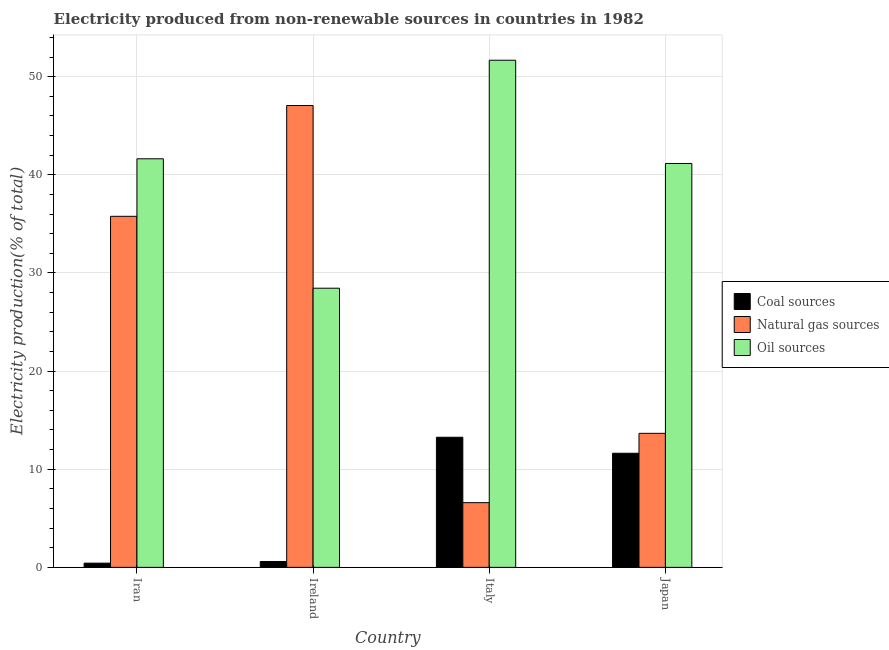How many different coloured bars are there?
Give a very brief answer. 3. How many bars are there on the 3rd tick from the left?
Offer a terse response. 3. What is the label of the 1st group of bars from the left?
Give a very brief answer. Iran. What is the percentage of electricity produced by coal in Iran?
Keep it short and to the point. 0.43. Across all countries, what is the maximum percentage of electricity produced by oil sources?
Provide a succinct answer. 51.67. Across all countries, what is the minimum percentage of electricity produced by oil sources?
Offer a very short reply. 28.44. In which country was the percentage of electricity produced by natural gas maximum?
Make the answer very short. Ireland. What is the total percentage of electricity produced by coal in the graph?
Your answer should be compact. 25.91. What is the difference between the percentage of electricity produced by oil sources in Iran and that in Ireland?
Your response must be concise. 13.19. What is the difference between the percentage of electricity produced by oil sources in Iran and the percentage of electricity produced by natural gas in Japan?
Provide a succinct answer. 27.97. What is the average percentage of electricity produced by natural gas per country?
Provide a succinct answer. 25.77. What is the difference between the percentage of electricity produced by coal and percentage of electricity produced by oil sources in Japan?
Your response must be concise. -29.52. What is the ratio of the percentage of electricity produced by coal in Italy to that in Japan?
Give a very brief answer. 1.14. What is the difference between the highest and the second highest percentage of electricity produced by natural gas?
Offer a terse response. 11.29. What is the difference between the highest and the lowest percentage of electricity produced by natural gas?
Your answer should be very brief. 40.46. In how many countries, is the percentage of electricity produced by natural gas greater than the average percentage of electricity produced by natural gas taken over all countries?
Your answer should be compact. 2. Is the sum of the percentage of electricity produced by coal in Iran and Ireland greater than the maximum percentage of electricity produced by natural gas across all countries?
Make the answer very short. No. What does the 1st bar from the left in Japan represents?
Your answer should be very brief. Coal sources. What does the 2nd bar from the right in Japan represents?
Keep it short and to the point. Natural gas sources. Is it the case that in every country, the sum of the percentage of electricity produced by coal and percentage of electricity produced by natural gas is greater than the percentage of electricity produced by oil sources?
Provide a short and direct response. No. How many bars are there?
Offer a very short reply. 12. Are all the bars in the graph horizontal?
Make the answer very short. No. What is the difference between two consecutive major ticks on the Y-axis?
Offer a very short reply. 10. Are the values on the major ticks of Y-axis written in scientific E-notation?
Your answer should be compact. No. Does the graph contain any zero values?
Your answer should be compact. No. Does the graph contain grids?
Your answer should be very brief. Yes. How many legend labels are there?
Ensure brevity in your answer.  3. What is the title of the graph?
Your response must be concise. Electricity produced from non-renewable sources in countries in 1982. Does "Oil" appear as one of the legend labels in the graph?
Keep it short and to the point. No. What is the Electricity production(% of total) in Coal sources in Iran?
Provide a short and direct response. 0.43. What is the Electricity production(% of total) of Natural gas sources in Iran?
Provide a short and direct response. 35.77. What is the Electricity production(% of total) of Oil sources in Iran?
Ensure brevity in your answer.  41.63. What is the Electricity production(% of total) of Coal sources in Ireland?
Make the answer very short. 0.6. What is the Electricity production(% of total) in Natural gas sources in Ireland?
Keep it short and to the point. 47.06. What is the Electricity production(% of total) in Oil sources in Ireland?
Your answer should be compact. 28.44. What is the Electricity production(% of total) in Coal sources in Italy?
Give a very brief answer. 13.26. What is the Electricity production(% of total) of Natural gas sources in Italy?
Your response must be concise. 6.59. What is the Electricity production(% of total) in Oil sources in Italy?
Your answer should be compact. 51.67. What is the Electricity production(% of total) of Coal sources in Japan?
Give a very brief answer. 11.63. What is the Electricity production(% of total) in Natural gas sources in Japan?
Give a very brief answer. 13.66. What is the Electricity production(% of total) of Oil sources in Japan?
Offer a very short reply. 41.15. Across all countries, what is the maximum Electricity production(% of total) in Coal sources?
Ensure brevity in your answer.  13.26. Across all countries, what is the maximum Electricity production(% of total) in Natural gas sources?
Your answer should be very brief. 47.06. Across all countries, what is the maximum Electricity production(% of total) in Oil sources?
Give a very brief answer. 51.67. Across all countries, what is the minimum Electricity production(% of total) of Coal sources?
Keep it short and to the point. 0.43. Across all countries, what is the minimum Electricity production(% of total) in Natural gas sources?
Ensure brevity in your answer.  6.59. Across all countries, what is the minimum Electricity production(% of total) in Oil sources?
Make the answer very short. 28.44. What is the total Electricity production(% of total) in Coal sources in the graph?
Offer a very short reply. 25.91. What is the total Electricity production(% of total) of Natural gas sources in the graph?
Keep it short and to the point. 103.07. What is the total Electricity production(% of total) of Oil sources in the graph?
Ensure brevity in your answer.  162.89. What is the difference between the Electricity production(% of total) in Coal sources in Iran and that in Ireland?
Make the answer very short. -0.17. What is the difference between the Electricity production(% of total) of Natural gas sources in Iran and that in Ireland?
Offer a very short reply. -11.29. What is the difference between the Electricity production(% of total) in Oil sources in Iran and that in Ireland?
Offer a terse response. 13.19. What is the difference between the Electricity production(% of total) in Coal sources in Iran and that in Italy?
Provide a succinct answer. -12.83. What is the difference between the Electricity production(% of total) in Natural gas sources in Iran and that in Italy?
Offer a very short reply. 29.18. What is the difference between the Electricity production(% of total) of Oil sources in Iran and that in Italy?
Provide a succinct answer. -10.04. What is the difference between the Electricity production(% of total) in Coal sources in Iran and that in Japan?
Ensure brevity in your answer.  -11.2. What is the difference between the Electricity production(% of total) of Natural gas sources in Iran and that in Japan?
Provide a short and direct response. 22.11. What is the difference between the Electricity production(% of total) of Oil sources in Iran and that in Japan?
Provide a succinct answer. 0.48. What is the difference between the Electricity production(% of total) in Coal sources in Ireland and that in Italy?
Offer a very short reply. -12.66. What is the difference between the Electricity production(% of total) in Natural gas sources in Ireland and that in Italy?
Your answer should be very brief. 40.46. What is the difference between the Electricity production(% of total) in Oil sources in Ireland and that in Italy?
Offer a terse response. -23.23. What is the difference between the Electricity production(% of total) in Coal sources in Ireland and that in Japan?
Provide a short and direct response. -11.03. What is the difference between the Electricity production(% of total) in Natural gas sources in Ireland and that in Japan?
Provide a succinct answer. 33.4. What is the difference between the Electricity production(% of total) of Oil sources in Ireland and that in Japan?
Offer a very short reply. -12.71. What is the difference between the Electricity production(% of total) in Coal sources in Italy and that in Japan?
Provide a short and direct response. 1.63. What is the difference between the Electricity production(% of total) in Natural gas sources in Italy and that in Japan?
Keep it short and to the point. -7.06. What is the difference between the Electricity production(% of total) in Oil sources in Italy and that in Japan?
Give a very brief answer. 10.52. What is the difference between the Electricity production(% of total) in Coal sources in Iran and the Electricity production(% of total) in Natural gas sources in Ireland?
Offer a terse response. -46.63. What is the difference between the Electricity production(% of total) in Coal sources in Iran and the Electricity production(% of total) in Oil sources in Ireland?
Your answer should be very brief. -28.01. What is the difference between the Electricity production(% of total) in Natural gas sources in Iran and the Electricity production(% of total) in Oil sources in Ireland?
Your answer should be very brief. 7.33. What is the difference between the Electricity production(% of total) of Coal sources in Iran and the Electricity production(% of total) of Natural gas sources in Italy?
Give a very brief answer. -6.16. What is the difference between the Electricity production(% of total) of Coal sources in Iran and the Electricity production(% of total) of Oil sources in Italy?
Your response must be concise. -51.24. What is the difference between the Electricity production(% of total) of Natural gas sources in Iran and the Electricity production(% of total) of Oil sources in Italy?
Provide a short and direct response. -15.9. What is the difference between the Electricity production(% of total) of Coal sources in Iran and the Electricity production(% of total) of Natural gas sources in Japan?
Your answer should be compact. -13.23. What is the difference between the Electricity production(% of total) of Coal sources in Iran and the Electricity production(% of total) of Oil sources in Japan?
Your answer should be very brief. -40.72. What is the difference between the Electricity production(% of total) in Natural gas sources in Iran and the Electricity production(% of total) in Oil sources in Japan?
Keep it short and to the point. -5.38. What is the difference between the Electricity production(% of total) of Coal sources in Ireland and the Electricity production(% of total) of Natural gas sources in Italy?
Provide a succinct answer. -5.99. What is the difference between the Electricity production(% of total) in Coal sources in Ireland and the Electricity production(% of total) in Oil sources in Italy?
Your answer should be very brief. -51.07. What is the difference between the Electricity production(% of total) of Natural gas sources in Ireland and the Electricity production(% of total) of Oil sources in Italy?
Make the answer very short. -4.61. What is the difference between the Electricity production(% of total) of Coal sources in Ireland and the Electricity production(% of total) of Natural gas sources in Japan?
Offer a terse response. -13.06. What is the difference between the Electricity production(% of total) of Coal sources in Ireland and the Electricity production(% of total) of Oil sources in Japan?
Ensure brevity in your answer.  -40.55. What is the difference between the Electricity production(% of total) in Natural gas sources in Ireland and the Electricity production(% of total) in Oil sources in Japan?
Make the answer very short. 5.91. What is the difference between the Electricity production(% of total) of Coal sources in Italy and the Electricity production(% of total) of Natural gas sources in Japan?
Your answer should be very brief. -0.4. What is the difference between the Electricity production(% of total) of Coal sources in Italy and the Electricity production(% of total) of Oil sources in Japan?
Provide a short and direct response. -27.89. What is the difference between the Electricity production(% of total) of Natural gas sources in Italy and the Electricity production(% of total) of Oil sources in Japan?
Keep it short and to the point. -34.56. What is the average Electricity production(% of total) in Coal sources per country?
Provide a short and direct response. 6.48. What is the average Electricity production(% of total) of Natural gas sources per country?
Give a very brief answer. 25.77. What is the average Electricity production(% of total) in Oil sources per country?
Offer a terse response. 40.72. What is the difference between the Electricity production(% of total) of Coal sources and Electricity production(% of total) of Natural gas sources in Iran?
Your response must be concise. -35.34. What is the difference between the Electricity production(% of total) of Coal sources and Electricity production(% of total) of Oil sources in Iran?
Your answer should be very brief. -41.2. What is the difference between the Electricity production(% of total) in Natural gas sources and Electricity production(% of total) in Oil sources in Iran?
Your response must be concise. -5.86. What is the difference between the Electricity production(% of total) of Coal sources and Electricity production(% of total) of Natural gas sources in Ireland?
Keep it short and to the point. -46.46. What is the difference between the Electricity production(% of total) of Coal sources and Electricity production(% of total) of Oil sources in Ireland?
Ensure brevity in your answer.  -27.84. What is the difference between the Electricity production(% of total) of Natural gas sources and Electricity production(% of total) of Oil sources in Ireland?
Ensure brevity in your answer.  18.61. What is the difference between the Electricity production(% of total) of Coal sources and Electricity production(% of total) of Natural gas sources in Italy?
Provide a short and direct response. 6.66. What is the difference between the Electricity production(% of total) of Coal sources and Electricity production(% of total) of Oil sources in Italy?
Provide a succinct answer. -38.41. What is the difference between the Electricity production(% of total) in Natural gas sources and Electricity production(% of total) in Oil sources in Italy?
Your answer should be very brief. -45.08. What is the difference between the Electricity production(% of total) of Coal sources and Electricity production(% of total) of Natural gas sources in Japan?
Make the answer very short. -2.03. What is the difference between the Electricity production(% of total) of Coal sources and Electricity production(% of total) of Oil sources in Japan?
Your answer should be compact. -29.52. What is the difference between the Electricity production(% of total) of Natural gas sources and Electricity production(% of total) of Oil sources in Japan?
Provide a succinct answer. -27.5. What is the ratio of the Electricity production(% of total) of Coal sources in Iran to that in Ireland?
Your answer should be compact. 0.72. What is the ratio of the Electricity production(% of total) of Natural gas sources in Iran to that in Ireland?
Ensure brevity in your answer.  0.76. What is the ratio of the Electricity production(% of total) of Oil sources in Iran to that in Ireland?
Offer a very short reply. 1.46. What is the ratio of the Electricity production(% of total) of Coal sources in Iran to that in Italy?
Your response must be concise. 0.03. What is the ratio of the Electricity production(% of total) in Natural gas sources in Iran to that in Italy?
Keep it short and to the point. 5.43. What is the ratio of the Electricity production(% of total) in Oil sources in Iran to that in Italy?
Keep it short and to the point. 0.81. What is the ratio of the Electricity production(% of total) of Coal sources in Iran to that in Japan?
Your response must be concise. 0.04. What is the ratio of the Electricity production(% of total) in Natural gas sources in Iran to that in Japan?
Your answer should be compact. 2.62. What is the ratio of the Electricity production(% of total) in Oil sources in Iran to that in Japan?
Offer a very short reply. 1.01. What is the ratio of the Electricity production(% of total) of Coal sources in Ireland to that in Italy?
Give a very brief answer. 0.05. What is the ratio of the Electricity production(% of total) of Natural gas sources in Ireland to that in Italy?
Your answer should be compact. 7.14. What is the ratio of the Electricity production(% of total) in Oil sources in Ireland to that in Italy?
Offer a terse response. 0.55. What is the ratio of the Electricity production(% of total) in Coal sources in Ireland to that in Japan?
Offer a very short reply. 0.05. What is the ratio of the Electricity production(% of total) in Natural gas sources in Ireland to that in Japan?
Offer a very short reply. 3.45. What is the ratio of the Electricity production(% of total) of Oil sources in Ireland to that in Japan?
Keep it short and to the point. 0.69. What is the ratio of the Electricity production(% of total) of Coal sources in Italy to that in Japan?
Give a very brief answer. 1.14. What is the ratio of the Electricity production(% of total) in Natural gas sources in Italy to that in Japan?
Keep it short and to the point. 0.48. What is the ratio of the Electricity production(% of total) of Oil sources in Italy to that in Japan?
Your answer should be compact. 1.26. What is the difference between the highest and the second highest Electricity production(% of total) in Coal sources?
Offer a terse response. 1.63. What is the difference between the highest and the second highest Electricity production(% of total) in Natural gas sources?
Your answer should be compact. 11.29. What is the difference between the highest and the second highest Electricity production(% of total) in Oil sources?
Your answer should be compact. 10.04. What is the difference between the highest and the lowest Electricity production(% of total) in Coal sources?
Ensure brevity in your answer.  12.83. What is the difference between the highest and the lowest Electricity production(% of total) in Natural gas sources?
Provide a succinct answer. 40.46. What is the difference between the highest and the lowest Electricity production(% of total) in Oil sources?
Provide a succinct answer. 23.23. 